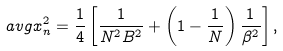Convert formula to latex. <formula><loc_0><loc_0><loc_500><loc_500>\ a v g { x _ { n } ^ { 2 } } & = \frac { 1 } { 4 } \left [ \frac { 1 } { N ^ { 2 } B ^ { 2 } } + \left ( 1 - \frac { 1 } { N } \right ) \frac { 1 } { \beta ^ { 2 } } \right ] ,</formula> 